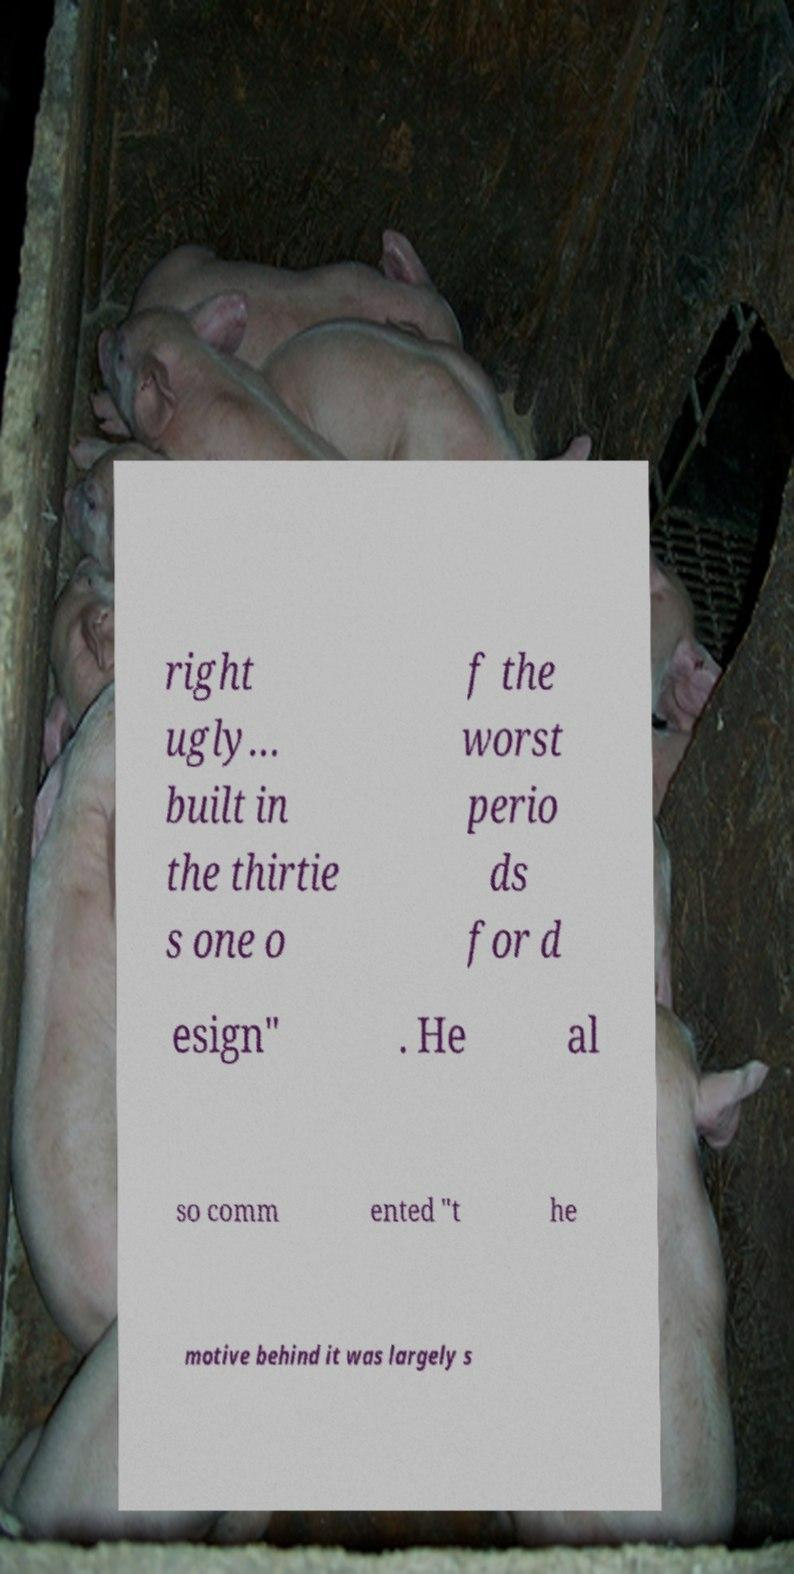Could you assist in decoding the text presented in this image and type it out clearly? right ugly… built in the thirtie s one o f the worst perio ds for d esign" . He al so comm ented "t he motive behind it was largely s 